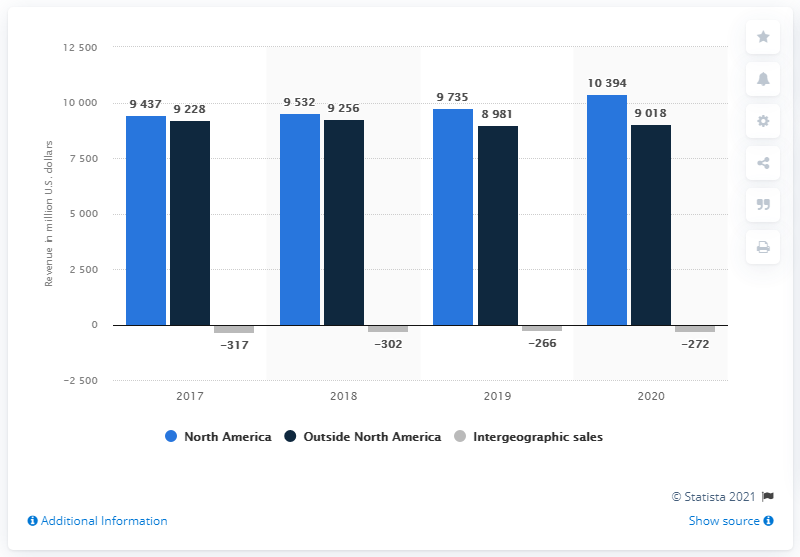Highlight a few significant elements in this photo. In North America, the revenue difference between the highest and lowest is approximately $957. Kimberly-Clark's North America revenues for the year 2020 were approximately $10,394 million. In 2017, Kimberly-Clark's net sales in North America increased. The highest revenue in North America is 10,394. 